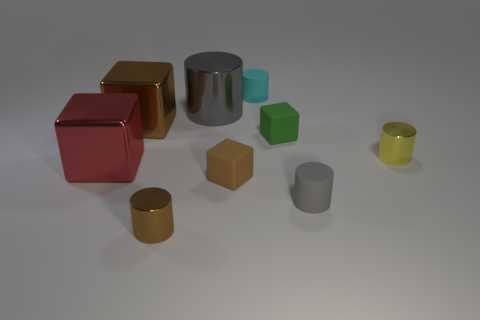There is a thing that is the same color as the big metallic cylinder; what is its material?
Offer a terse response. Rubber. There is a thing that is the same color as the big metallic cylinder; what is its size?
Give a very brief answer. Small. How many things are big metallic objects or tiny metallic things that are on the right side of the small cyan matte object?
Make the answer very short. 4. How many other objects are the same shape as the green matte object?
Offer a terse response. 3. Are there fewer gray rubber cylinders behind the cyan matte thing than metallic blocks on the right side of the small brown matte cube?
Ensure brevity in your answer.  No. Is there anything else that has the same material as the big cylinder?
Offer a terse response. Yes. What is the shape of the brown thing that is made of the same material as the green block?
Your answer should be compact. Cube. Are there any other things of the same color as the big cylinder?
Keep it short and to the point. Yes. There is a tiny metal cylinder that is on the right side of the brown cylinder in front of the gray metal thing; what color is it?
Give a very brief answer. Yellow. There is a thing that is behind the large metallic object on the right side of the small shiny object on the left side of the large shiny cylinder; what is its material?
Provide a succinct answer. Rubber. 